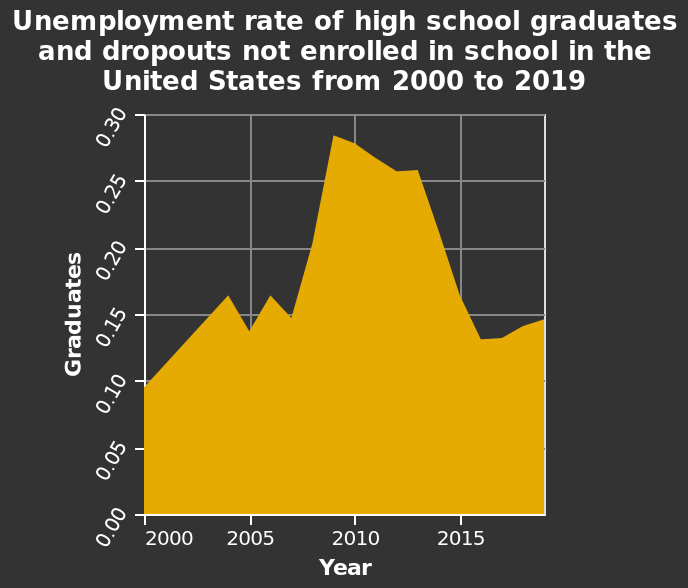<image>
Has the unemployment rate among high school graduates and dropouts been consistently decreasing since 2009? Yes, the unemployment rate has trended downward since 2009. Were there any changes in the unemployment rate among high school graduates and dropouts between 2000 and 2009? Yes, the unemployment rate increased during that period. please enumerates aspects of the construction of the chart This area diagram is called Unemployment rate of high school graduates and dropouts not enrolled in school in the United States from 2000 to 2019. The x-axis shows Year while the y-axis measures Graduates. What is the name of the area diagram? The area diagram is called "Unemployment rate of high school graduates and dropouts not enrolled in school in the United States from 2000 to 2019." What was the trend in the unemployment rate among high school graduates and dropouts from 2000 to around 2009?  The unemployment rate among high school graduates and dropouts was trending upward during that period. 